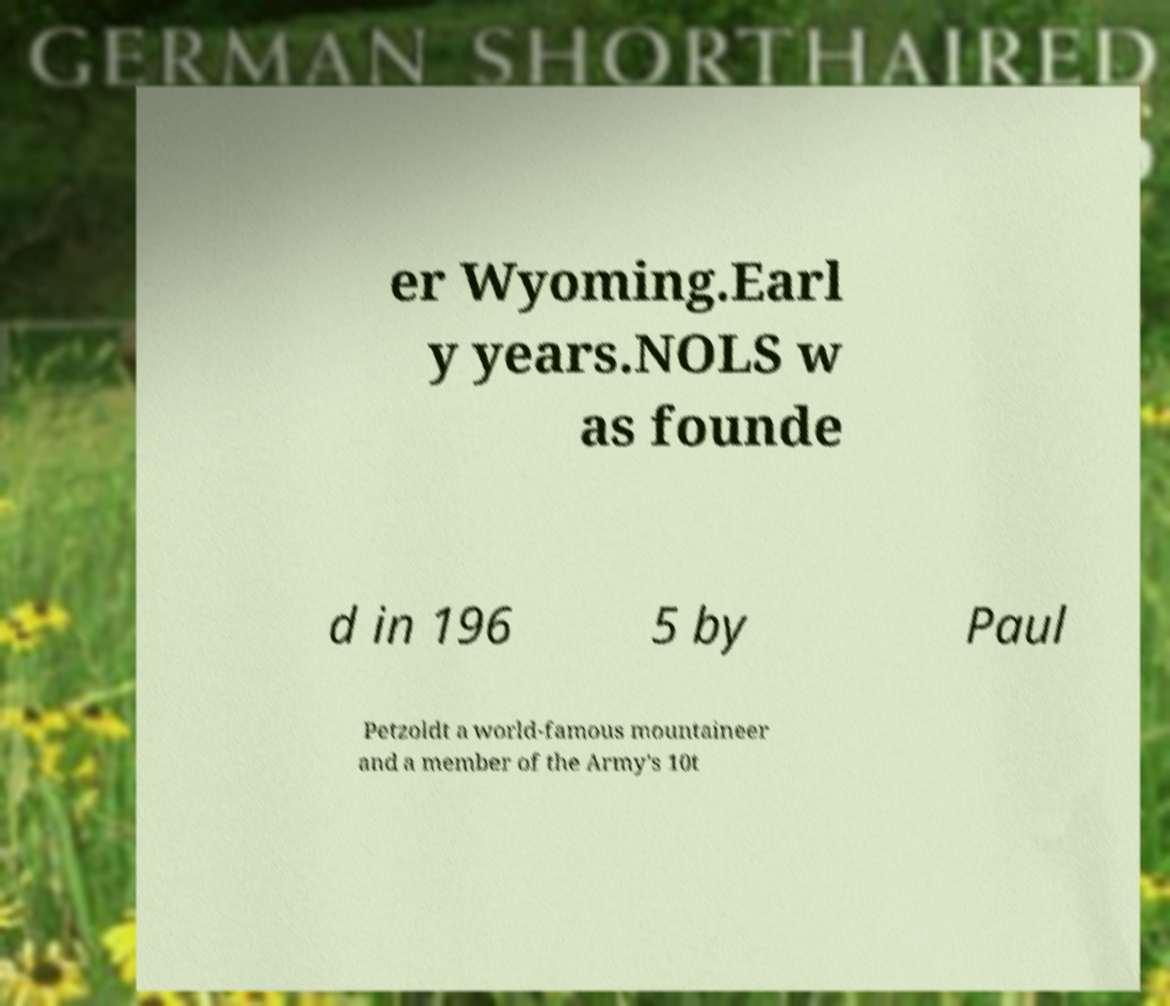Could you extract and type out the text from this image? er Wyoming.Earl y years.NOLS w as founde d in 196 5 by Paul Petzoldt a world-famous mountaineer and a member of the Army's 10t 